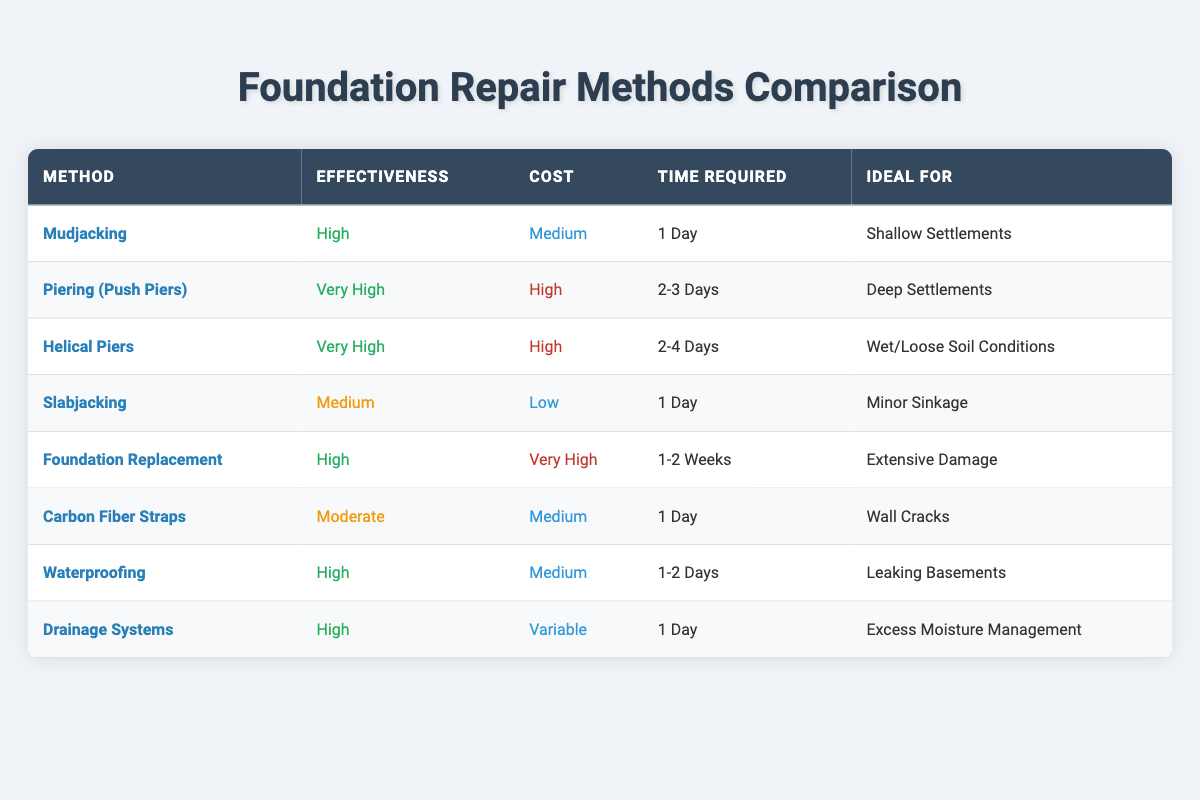What is the effectiveness of Mudjacking? Referring to the table, Mudjacking is listed under the "Effectiveness" column with a value of "High".
Answer: High How many days does it take for Foundation Replacement? In the table, Foundation Replacement is associated with the "Time Required" column that states it takes "1-2 Weeks".
Answer: 1-2 Weeks Which method is ideal for Deep Settlements? The table shows that "Piering (Push Piers)" is listed under the "Ideal For" column for Deep Settlements.
Answer: Piering (Push Piers) Is Slabjacking effective for wall cracks? The "Ideal For" column states that Slabjacking is suitable for "Minor Sinkage", not wall cracks, therefore the statement is false.
Answer: No Considering cost, which method has the highest effectiveness? The effectiveness ratings of each method are compared in the table, where "Piering (Push Piers)" and "Helical Piers" both are "Very High" but have a high cost. However, Foundation Replacement is also "High" effectiveness but with a very high cost. It's a tie in effectiveness, but cost is highest for Foundation Replacement.
Answer: Foundation Replacement What is the average effectiveness level of all methods? Calculating the effectiveness levels: (High, Very High, Very High, Medium, High, Moderate, High, High) translates to numerical values for each (High=2, Very High=3, Medium=1, Moderate=1.5). Thus, the average can be computed as (2 + 3 + 3 + 1 + 2 + 1.5 + 2 + 2) / 8 = 1.8125 which roughly corresponds to Moderate.
Answer: Moderate Do any repair methods require more than 4 days? Evaluating the "Time Required" column, only Foundation Replacement of "1-2 Weeks" exceeds 4 days, thus the answer is true for this query.
Answer: Yes Which repair method is the most cost-effective? Looking at the "Cost" column, Slabjacking shows the lowest cost as "Low". Therefore, it can be identified as the most cost-effective method in the table.
Answer: Slabjacking What is the effectiveness of methods ideal for Wet/Loose Soil Conditions? The only method suitable for Wet/Loose Soil Conditions, as indicated in the table, is "Helical Piers" which is categorized with an effectiveness of "Very High".
Answer: Very High 